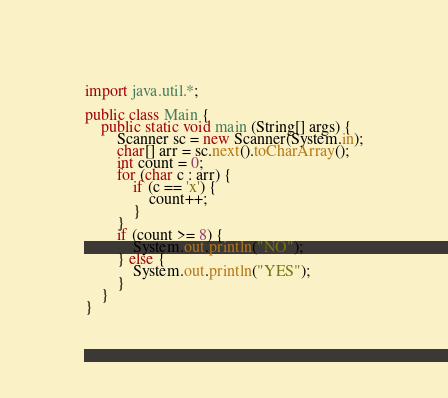Convert code to text. <code><loc_0><loc_0><loc_500><loc_500><_Java_>import java.util.*;

public class Main {
	public static void main (String[] args) {
		Scanner sc = new Scanner(System.in);
		char[] arr = sc.next().toCharArray();
		int count = 0;
		for (char c : arr) {
			if (c == 'x') {
				count++;
			}
		}
		if (count >= 8) {
			System.out.println("NO");
		} else {
			System.out.println("YES");
		}
	}
}
</code> 